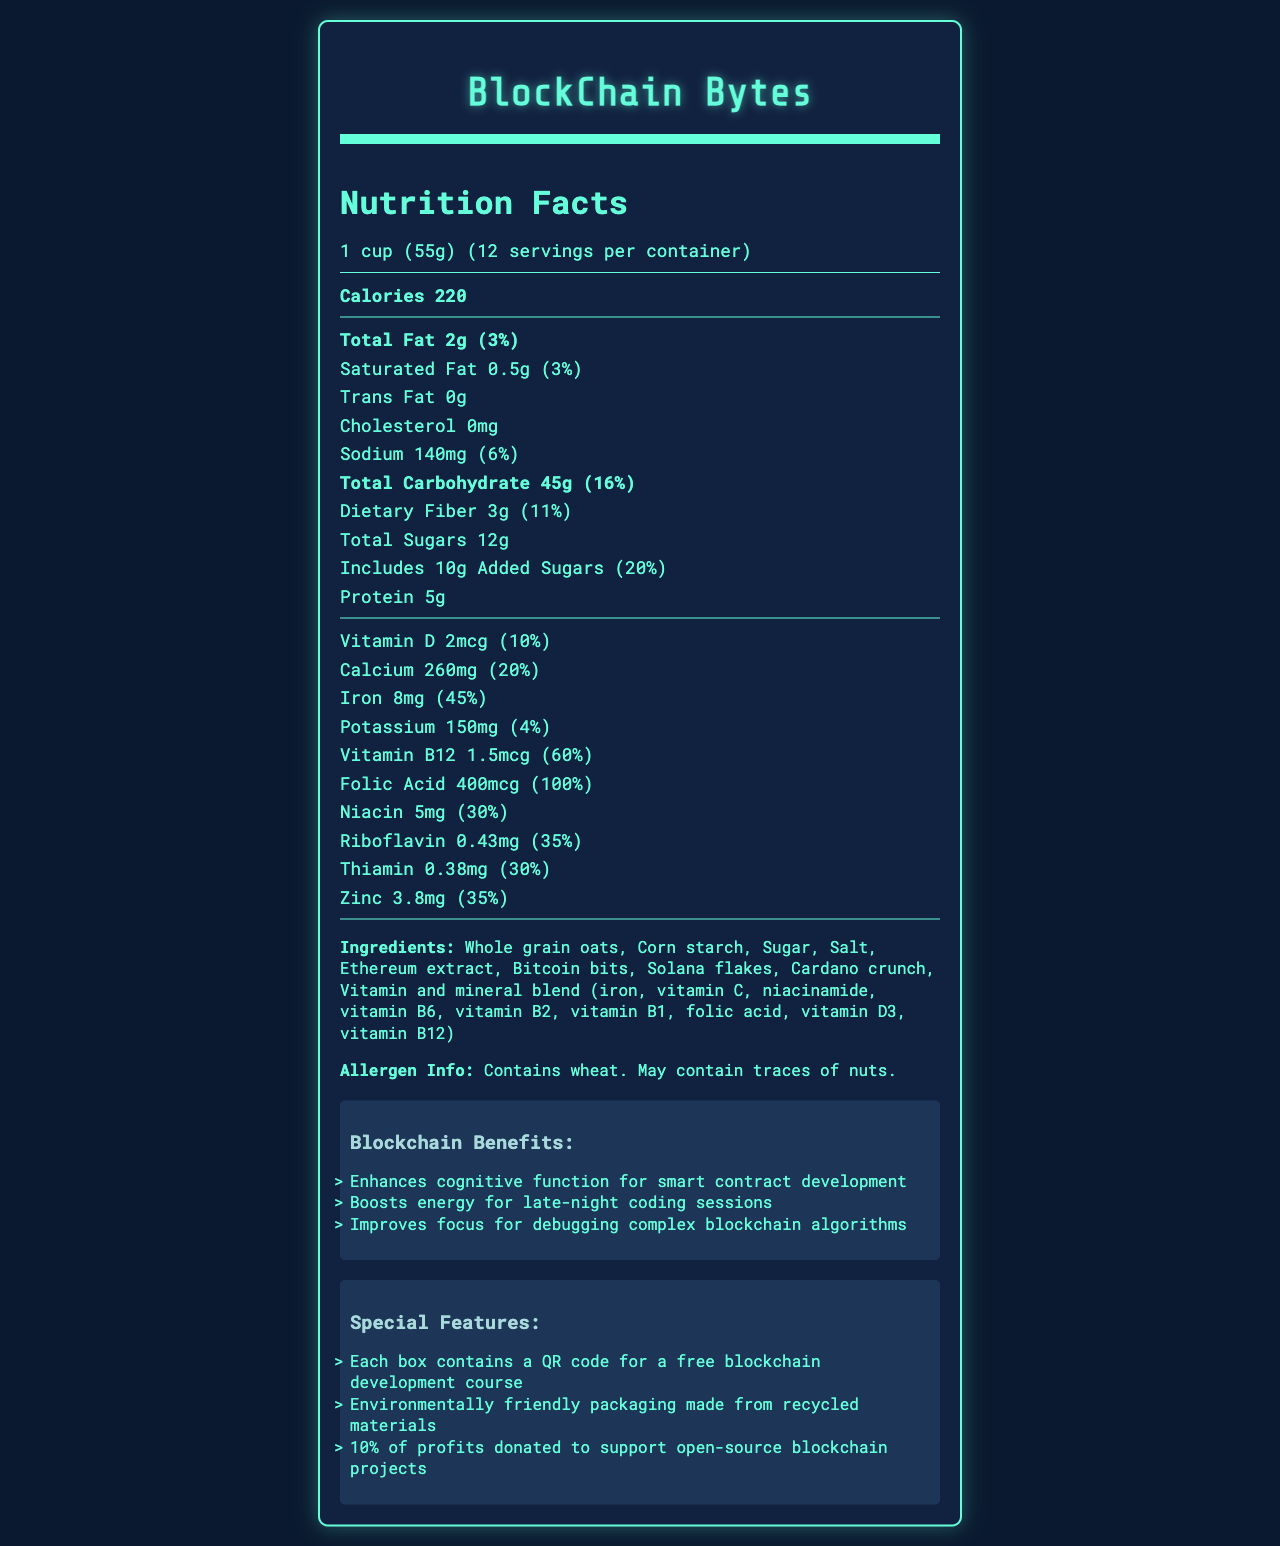What is the serving size for BlockChain Bytes? The document states that the serving size is 1 cup (55g).
Answer: 1 cup (55g) How many servings are in one container of BlockChain Bytes? The document mentions that there are 12 servings per container.
Answer: 12 How many calories are in a single serving of BlockChain Bytes? According to the document, each serving contains 220 calories.
Answer: 220 What is the total carbohydrate content in one serving? The nutrition facts indicate that the total carbohydrate content per serving is 45g.
Answer: 45g How much iron does one serving provide? The document specifies that one serving contains 8mg of iron, which is 45% of the daily value.
Answer: 8mg (45% DV) What amount of dietary fiber is in each serving of BlockChain Bytes? The dietary fiber content per serving is listed as 3g.
Answer: 3g How much of the daily value for added sugars is contained in one serving? The document shows that the added sugars account for 20% of the daily value.
Answer: 20% Identify an ingredient in BlockChain Bytes related to blockchain technology. A. Whole grain oats B. Ethereum extract C. Sugar D. Salt The list of ingredients includes "Ethereum extract," which is related to blockchain technology.
Answer: B Which vitamin is provided in the highest percentage of the daily value per serving? A. Vitamin D (10%) B. Calcium (20%) C. Iron (45%) D. Vitamin B12 (60%) Vitamin B12 provides 60% of the daily value per serving, the highest percentage listed.
Answer: D Are there any allergens in BlockChain Bytes? Yes or No The allergen information section notes that the product contains wheat and may contain traces of nuts.
Answer: Yes Summarize the document. The document provides the nutrition facts and ingredients for BlockChain Bytes cereal. It includes serving size, number of servings, calorie count, and detailed nutritional information such as fats, cholesterol, sodium, carbohydrates, and various vitamins and minerals. Additionally, it lists ingredients, allergen information, and outlines benefits related to cognitive function and blockchain development, as well as special features like QR codes for courses and environmental packaging.
Answer: BlockChain Bytes Nutrition Facts What benefits for blockchain developers does BlockChain Bytes offer? The benefits listed in the document include enhancing cognitive function, boosting energy for late-night coding, and improving focus for debugging complex blockchain algorithms.
Answer: Enhances cognitive function, boosts energy, improves focus How much calcium is in each serving? The document indicates that each serving contains 260mg of calcium, which is 20% of the daily value.
Answer: 260mg (20% DV) What special feature does each box of BlockChain Bytes include? The special features section notes that each box contains a QR code for a free blockchain development course.
Answer: QR code for a free blockchain development course Can the exact process of manufacturing BlockChain Bytes be determined from the document? The document does not provide details about the manufacturing process. It only lists nutrition facts, ingredients, benefits, and special features.
Answer: Not enough information 